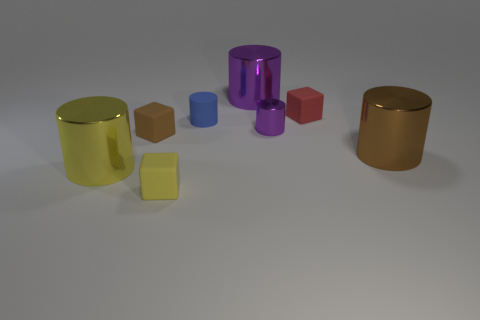The large object that is both behind the yellow shiny thing and left of the red block has what shape?
Offer a terse response. Cylinder. How many purple things are either matte things or big blocks?
Provide a short and direct response. 0. There is a small matte cube that is behind the small purple cylinder; is its color the same as the small shiny thing?
Make the answer very short. No. What size is the brown thing that is on the right side of the small cylinder that is behind the tiny purple metallic object?
Provide a succinct answer. Large. What material is the purple thing that is the same size as the brown block?
Offer a very short reply. Metal. How many other objects are the same size as the brown metallic object?
Keep it short and to the point. 2. What number of balls are either big brown things or small purple metal things?
Your answer should be very brief. 0. Are there any other things that are the same material as the small brown cube?
Keep it short and to the point. Yes. There is a tiny cube that is in front of the cube on the left side of the tiny cube in front of the small brown cube; what is it made of?
Your answer should be very brief. Rubber. There is a object that is the same color as the tiny metallic cylinder; what is it made of?
Give a very brief answer. Metal. 